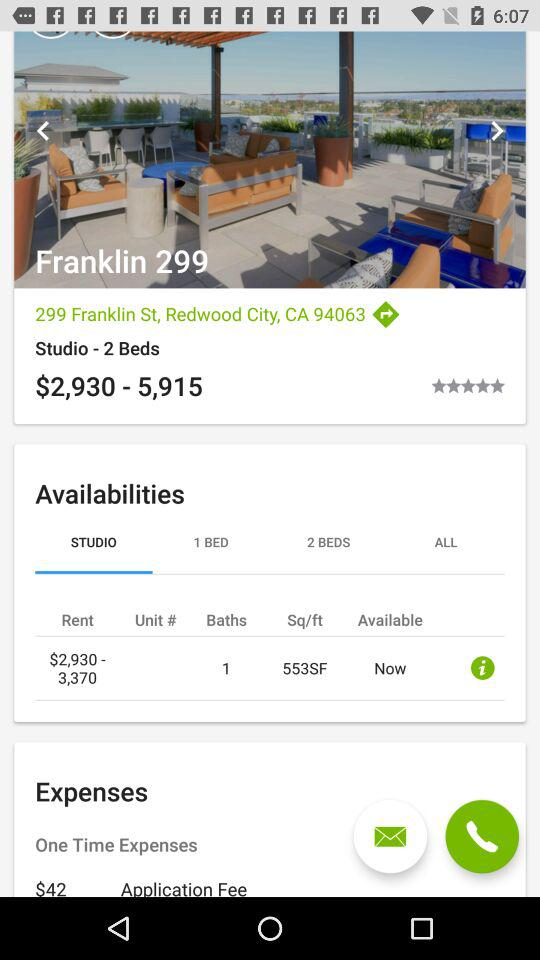How much is the rent for the studio? The rent for the studio ranges from $2,930 to $3,370. 